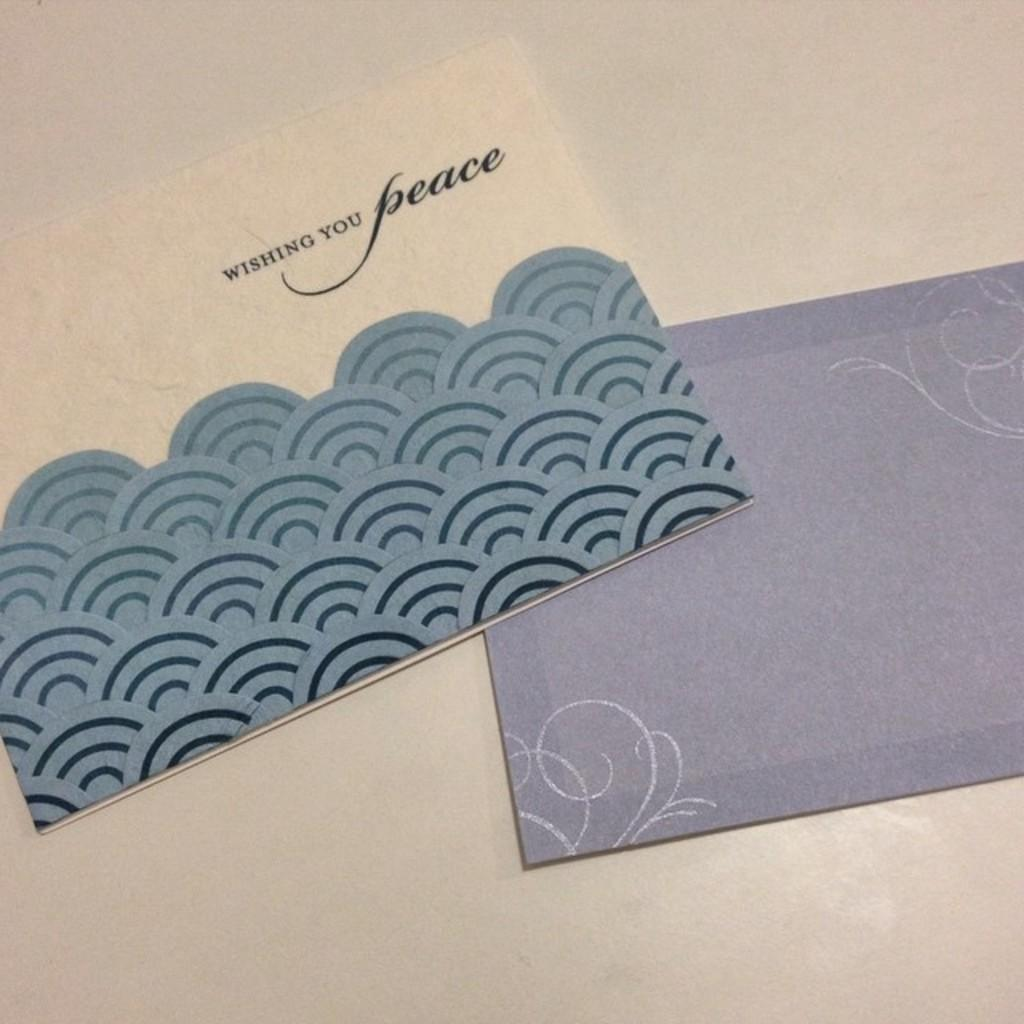<image>
Give a short and clear explanation of the subsequent image. A tan and blue card Wishing You Peace sits on the corner of a blue envelope. 